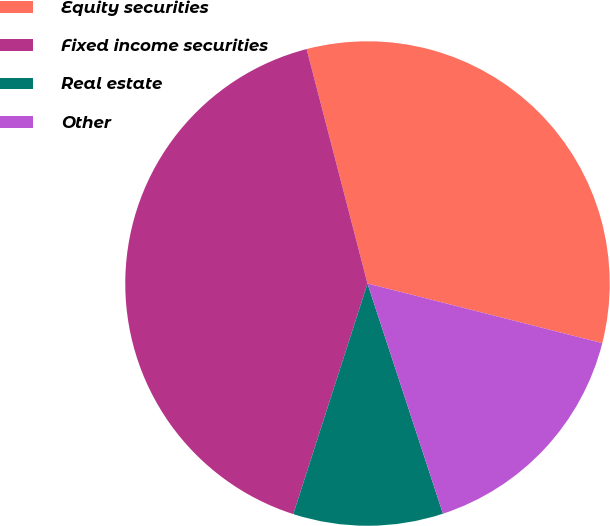Convert chart. <chart><loc_0><loc_0><loc_500><loc_500><pie_chart><fcel>Equity securities<fcel>Fixed income securities<fcel>Real estate<fcel>Other<nl><fcel>33.0%<fcel>41.0%<fcel>10.0%<fcel>16.0%<nl></chart> 